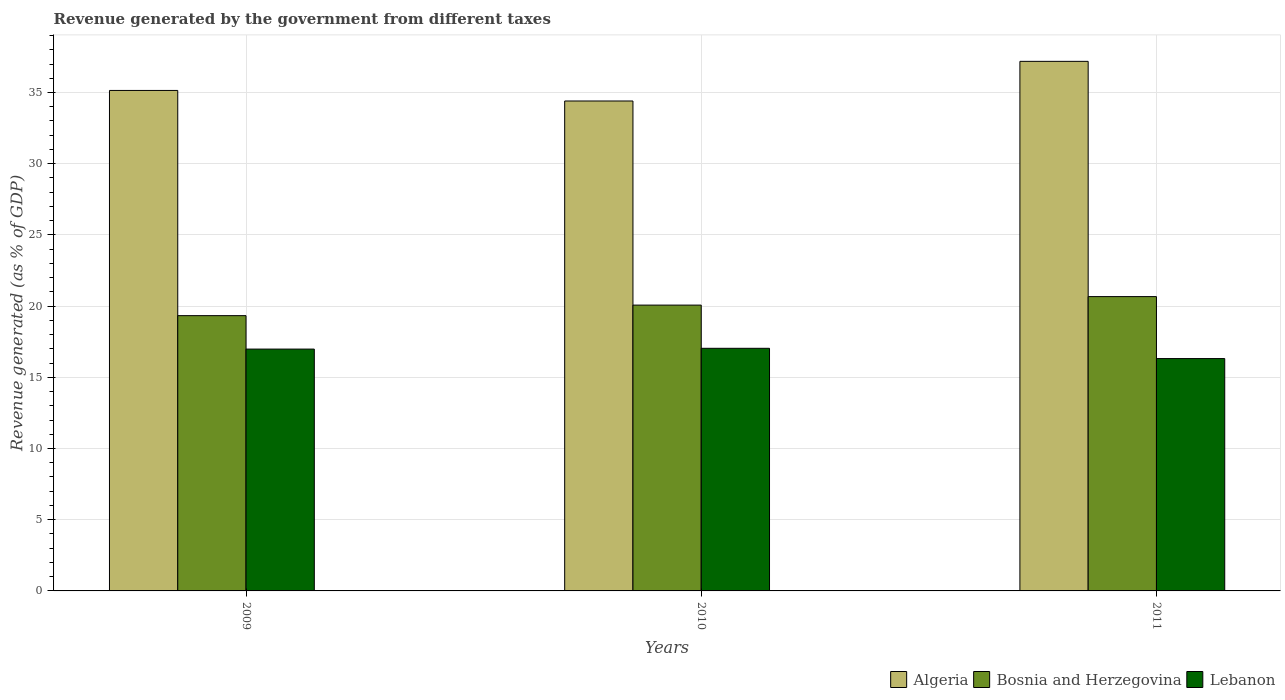How many groups of bars are there?
Keep it short and to the point. 3. Are the number of bars per tick equal to the number of legend labels?
Offer a terse response. Yes. Are the number of bars on each tick of the X-axis equal?
Offer a very short reply. Yes. What is the revenue generated by the government in Algeria in 2009?
Your answer should be very brief. 35.14. Across all years, what is the maximum revenue generated by the government in Bosnia and Herzegovina?
Your response must be concise. 20.67. Across all years, what is the minimum revenue generated by the government in Algeria?
Give a very brief answer. 34.4. In which year was the revenue generated by the government in Bosnia and Herzegovina minimum?
Ensure brevity in your answer.  2009. What is the total revenue generated by the government in Algeria in the graph?
Make the answer very short. 106.73. What is the difference between the revenue generated by the government in Bosnia and Herzegovina in 2010 and that in 2011?
Your answer should be very brief. -0.6. What is the difference between the revenue generated by the government in Bosnia and Herzegovina in 2010 and the revenue generated by the government in Lebanon in 2009?
Provide a short and direct response. 3.09. What is the average revenue generated by the government in Algeria per year?
Offer a very short reply. 35.58. In the year 2010, what is the difference between the revenue generated by the government in Lebanon and revenue generated by the government in Bosnia and Herzegovina?
Your response must be concise. -3.03. What is the ratio of the revenue generated by the government in Algeria in 2010 to that in 2011?
Offer a terse response. 0.93. What is the difference between the highest and the second highest revenue generated by the government in Algeria?
Your response must be concise. 2.04. What is the difference between the highest and the lowest revenue generated by the government in Algeria?
Your answer should be very brief. 2.78. What does the 3rd bar from the left in 2009 represents?
Ensure brevity in your answer.  Lebanon. What does the 2nd bar from the right in 2011 represents?
Your answer should be compact. Bosnia and Herzegovina. How many bars are there?
Give a very brief answer. 9. Are all the bars in the graph horizontal?
Offer a terse response. No. How many years are there in the graph?
Keep it short and to the point. 3. Does the graph contain any zero values?
Provide a short and direct response. No. Does the graph contain grids?
Make the answer very short. Yes. How are the legend labels stacked?
Make the answer very short. Horizontal. What is the title of the graph?
Provide a succinct answer. Revenue generated by the government from different taxes. Does "Germany" appear as one of the legend labels in the graph?
Offer a very short reply. No. What is the label or title of the X-axis?
Give a very brief answer. Years. What is the label or title of the Y-axis?
Your response must be concise. Revenue generated (as % of GDP). What is the Revenue generated (as % of GDP) of Algeria in 2009?
Your answer should be compact. 35.14. What is the Revenue generated (as % of GDP) of Bosnia and Herzegovina in 2009?
Your answer should be very brief. 19.33. What is the Revenue generated (as % of GDP) of Lebanon in 2009?
Your response must be concise. 16.98. What is the Revenue generated (as % of GDP) in Algeria in 2010?
Your answer should be compact. 34.4. What is the Revenue generated (as % of GDP) in Bosnia and Herzegovina in 2010?
Your answer should be very brief. 20.07. What is the Revenue generated (as % of GDP) in Lebanon in 2010?
Your answer should be very brief. 17.04. What is the Revenue generated (as % of GDP) in Algeria in 2011?
Offer a terse response. 37.19. What is the Revenue generated (as % of GDP) in Bosnia and Herzegovina in 2011?
Offer a very short reply. 20.67. What is the Revenue generated (as % of GDP) in Lebanon in 2011?
Your response must be concise. 16.32. Across all years, what is the maximum Revenue generated (as % of GDP) of Algeria?
Your answer should be very brief. 37.19. Across all years, what is the maximum Revenue generated (as % of GDP) of Bosnia and Herzegovina?
Your answer should be very brief. 20.67. Across all years, what is the maximum Revenue generated (as % of GDP) of Lebanon?
Offer a terse response. 17.04. Across all years, what is the minimum Revenue generated (as % of GDP) in Algeria?
Make the answer very short. 34.4. Across all years, what is the minimum Revenue generated (as % of GDP) in Bosnia and Herzegovina?
Your response must be concise. 19.33. Across all years, what is the minimum Revenue generated (as % of GDP) of Lebanon?
Your response must be concise. 16.32. What is the total Revenue generated (as % of GDP) in Algeria in the graph?
Keep it short and to the point. 106.73. What is the total Revenue generated (as % of GDP) of Bosnia and Herzegovina in the graph?
Give a very brief answer. 60.07. What is the total Revenue generated (as % of GDP) of Lebanon in the graph?
Keep it short and to the point. 50.33. What is the difference between the Revenue generated (as % of GDP) in Algeria in 2009 and that in 2010?
Provide a short and direct response. 0.74. What is the difference between the Revenue generated (as % of GDP) in Bosnia and Herzegovina in 2009 and that in 2010?
Your answer should be compact. -0.74. What is the difference between the Revenue generated (as % of GDP) of Lebanon in 2009 and that in 2010?
Your response must be concise. -0.06. What is the difference between the Revenue generated (as % of GDP) in Algeria in 2009 and that in 2011?
Make the answer very short. -2.04. What is the difference between the Revenue generated (as % of GDP) of Bosnia and Herzegovina in 2009 and that in 2011?
Keep it short and to the point. -1.34. What is the difference between the Revenue generated (as % of GDP) in Lebanon in 2009 and that in 2011?
Keep it short and to the point. 0.67. What is the difference between the Revenue generated (as % of GDP) of Algeria in 2010 and that in 2011?
Ensure brevity in your answer.  -2.78. What is the difference between the Revenue generated (as % of GDP) in Bosnia and Herzegovina in 2010 and that in 2011?
Your response must be concise. -0.6. What is the difference between the Revenue generated (as % of GDP) in Lebanon in 2010 and that in 2011?
Offer a terse response. 0.72. What is the difference between the Revenue generated (as % of GDP) in Algeria in 2009 and the Revenue generated (as % of GDP) in Bosnia and Herzegovina in 2010?
Give a very brief answer. 15.07. What is the difference between the Revenue generated (as % of GDP) of Algeria in 2009 and the Revenue generated (as % of GDP) of Lebanon in 2010?
Ensure brevity in your answer.  18.11. What is the difference between the Revenue generated (as % of GDP) of Bosnia and Herzegovina in 2009 and the Revenue generated (as % of GDP) of Lebanon in 2010?
Provide a short and direct response. 2.29. What is the difference between the Revenue generated (as % of GDP) of Algeria in 2009 and the Revenue generated (as % of GDP) of Bosnia and Herzegovina in 2011?
Keep it short and to the point. 14.48. What is the difference between the Revenue generated (as % of GDP) in Algeria in 2009 and the Revenue generated (as % of GDP) in Lebanon in 2011?
Offer a very short reply. 18.83. What is the difference between the Revenue generated (as % of GDP) in Bosnia and Herzegovina in 2009 and the Revenue generated (as % of GDP) in Lebanon in 2011?
Provide a succinct answer. 3.01. What is the difference between the Revenue generated (as % of GDP) of Algeria in 2010 and the Revenue generated (as % of GDP) of Bosnia and Herzegovina in 2011?
Give a very brief answer. 13.74. What is the difference between the Revenue generated (as % of GDP) of Algeria in 2010 and the Revenue generated (as % of GDP) of Lebanon in 2011?
Provide a succinct answer. 18.09. What is the difference between the Revenue generated (as % of GDP) in Bosnia and Herzegovina in 2010 and the Revenue generated (as % of GDP) in Lebanon in 2011?
Keep it short and to the point. 3.76. What is the average Revenue generated (as % of GDP) in Algeria per year?
Make the answer very short. 35.58. What is the average Revenue generated (as % of GDP) of Bosnia and Herzegovina per year?
Offer a very short reply. 20.02. What is the average Revenue generated (as % of GDP) of Lebanon per year?
Provide a short and direct response. 16.78. In the year 2009, what is the difference between the Revenue generated (as % of GDP) of Algeria and Revenue generated (as % of GDP) of Bosnia and Herzegovina?
Offer a very short reply. 15.81. In the year 2009, what is the difference between the Revenue generated (as % of GDP) of Algeria and Revenue generated (as % of GDP) of Lebanon?
Offer a terse response. 18.16. In the year 2009, what is the difference between the Revenue generated (as % of GDP) of Bosnia and Herzegovina and Revenue generated (as % of GDP) of Lebanon?
Offer a very short reply. 2.35. In the year 2010, what is the difference between the Revenue generated (as % of GDP) in Algeria and Revenue generated (as % of GDP) in Bosnia and Herzegovina?
Ensure brevity in your answer.  14.33. In the year 2010, what is the difference between the Revenue generated (as % of GDP) of Algeria and Revenue generated (as % of GDP) of Lebanon?
Your answer should be very brief. 17.37. In the year 2010, what is the difference between the Revenue generated (as % of GDP) of Bosnia and Herzegovina and Revenue generated (as % of GDP) of Lebanon?
Provide a succinct answer. 3.03. In the year 2011, what is the difference between the Revenue generated (as % of GDP) of Algeria and Revenue generated (as % of GDP) of Bosnia and Herzegovina?
Your answer should be very brief. 16.52. In the year 2011, what is the difference between the Revenue generated (as % of GDP) of Algeria and Revenue generated (as % of GDP) of Lebanon?
Offer a terse response. 20.87. In the year 2011, what is the difference between the Revenue generated (as % of GDP) of Bosnia and Herzegovina and Revenue generated (as % of GDP) of Lebanon?
Offer a very short reply. 4.35. What is the ratio of the Revenue generated (as % of GDP) of Algeria in 2009 to that in 2010?
Offer a terse response. 1.02. What is the ratio of the Revenue generated (as % of GDP) of Bosnia and Herzegovina in 2009 to that in 2010?
Give a very brief answer. 0.96. What is the ratio of the Revenue generated (as % of GDP) in Lebanon in 2009 to that in 2010?
Your response must be concise. 1. What is the ratio of the Revenue generated (as % of GDP) of Algeria in 2009 to that in 2011?
Offer a very short reply. 0.95. What is the ratio of the Revenue generated (as % of GDP) of Bosnia and Herzegovina in 2009 to that in 2011?
Offer a very short reply. 0.94. What is the ratio of the Revenue generated (as % of GDP) of Lebanon in 2009 to that in 2011?
Provide a short and direct response. 1.04. What is the ratio of the Revenue generated (as % of GDP) in Algeria in 2010 to that in 2011?
Make the answer very short. 0.93. What is the ratio of the Revenue generated (as % of GDP) of Bosnia and Herzegovina in 2010 to that in 2011?
Keep it short and to the point. 0.97. What is the ratio of the Revenue generated (as % of GDP) in Lebanon in 2010 to that in 2011?
Your response must be concise. 1.04. What is the difference between the highest and the second highest Revenue generated (as % of GDP) in Algeria?
Make the answer very short. 2.04. What is the difference between the highest and the second highest Revenue generated (as % of GDP) of Bosnia and Herzegovina?
Make the answer very short. 0.6. What is the difference between the highest and the second highest Revenue generated (as % of GDP) of Lebanon?
Your answer should be very brief. 0.06. What is the difference between the highest and the lowest Revenue generated (as % of GDP) in Algeria?
Ensure brevity in your answer.  2.78. What is the difference between the highest and the lowest Revenue generated (as % of GDP) in Bosnia and Herzegovina?
Provide a succinct answer. 1.34. What is the difference between the highest and the lowest Revenue generated (as % of GDP) in Lebanon?
Give a very brief answer. 0.72. 